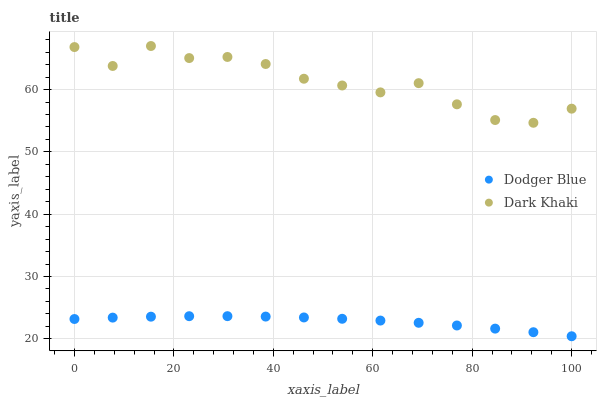Does Dodger Blue have the minimum area under the curve?
Answer yes or no. Yes. Does Dark Khaki have the maximum area under the curve?
Answer yes or no. Yes. Does Dodger Blue have the maximum area under the curve?
Answer yes or no. No. Is Dodger Blue the smoothest?
Answer yes or no. Yes. Is Dark Khaki the roughest?
Answer yes or no. Yes. Is Dodger Blue the roughest?
Answer yes or no. No. Does Dodger Blue have the lowest value?
Answer yes or no. Yes. Does Dark Khaki have the highest value?
Answer yes or no. Yes. Does Dodger Blue have the highest value?
Answer yes or no. No. Is Dodger Blue less than Dark Khaki?
Answer yes or no. Yes. Is Dark Khaki greater than Dodger Blue?
Answer yes or no. Yes. Does Dodger Blue intersect Dark Khaki?
Answer yes or no. No. 